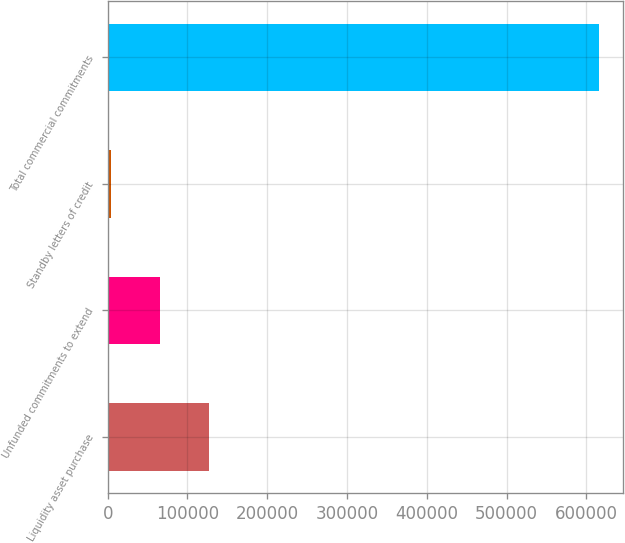<chart> <loc_0><loc_0><loc_500><loc_500><bar_chart><fcel>Liquidity asset purchase<fcel>Unfunded commitments to extend<fcel>Standby letters of credit<fcel>Total commercial commitments<nl><fcel>126649<fcel>65576.9<fcel>4505<fcel>615224<nl></chart> 